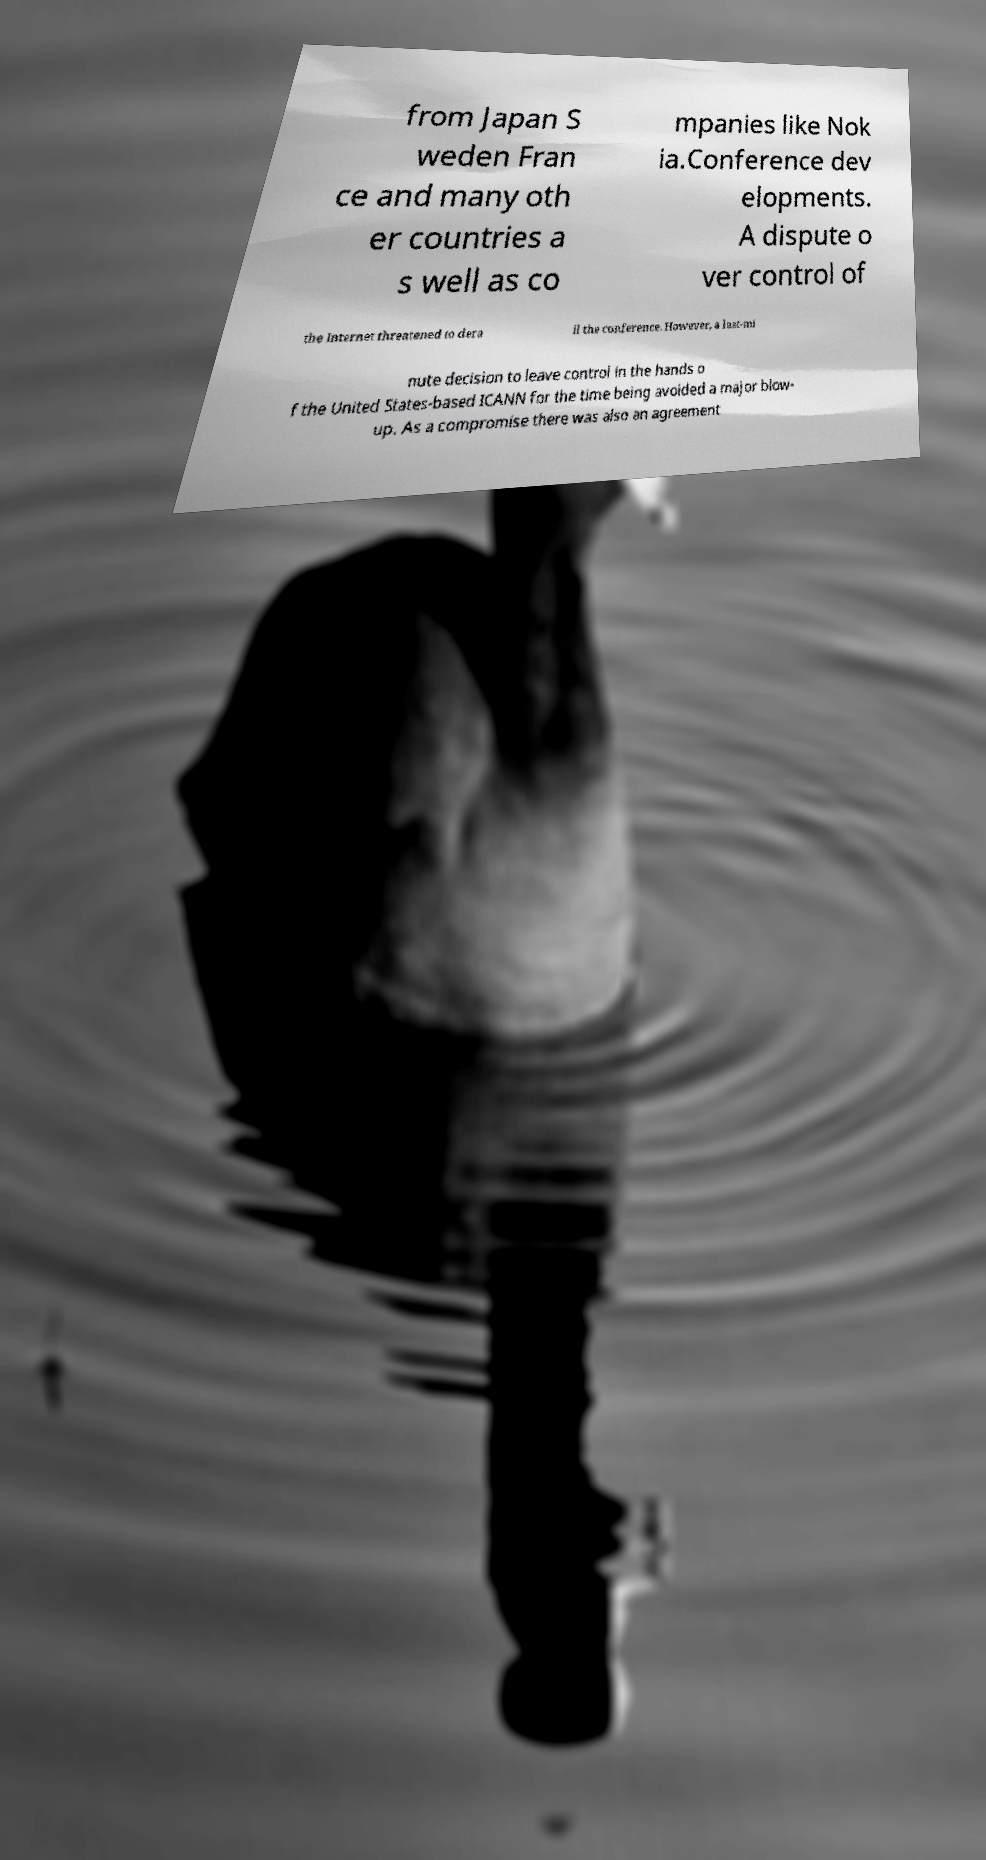Could you assist in decoding the text presented in this image and type it out clearly? from Japan S weden Fran ce and many oth er countries a s well as co mpanies like Nok ia.Conference dev elopments. A dispute o ver control of the Internet threatened to dera il the conference. However, a last-mi nute decision to leave control in the hands o f the United States-based ICANN for the time being avoided a major blow- up. As a compromise there was also an agreement 